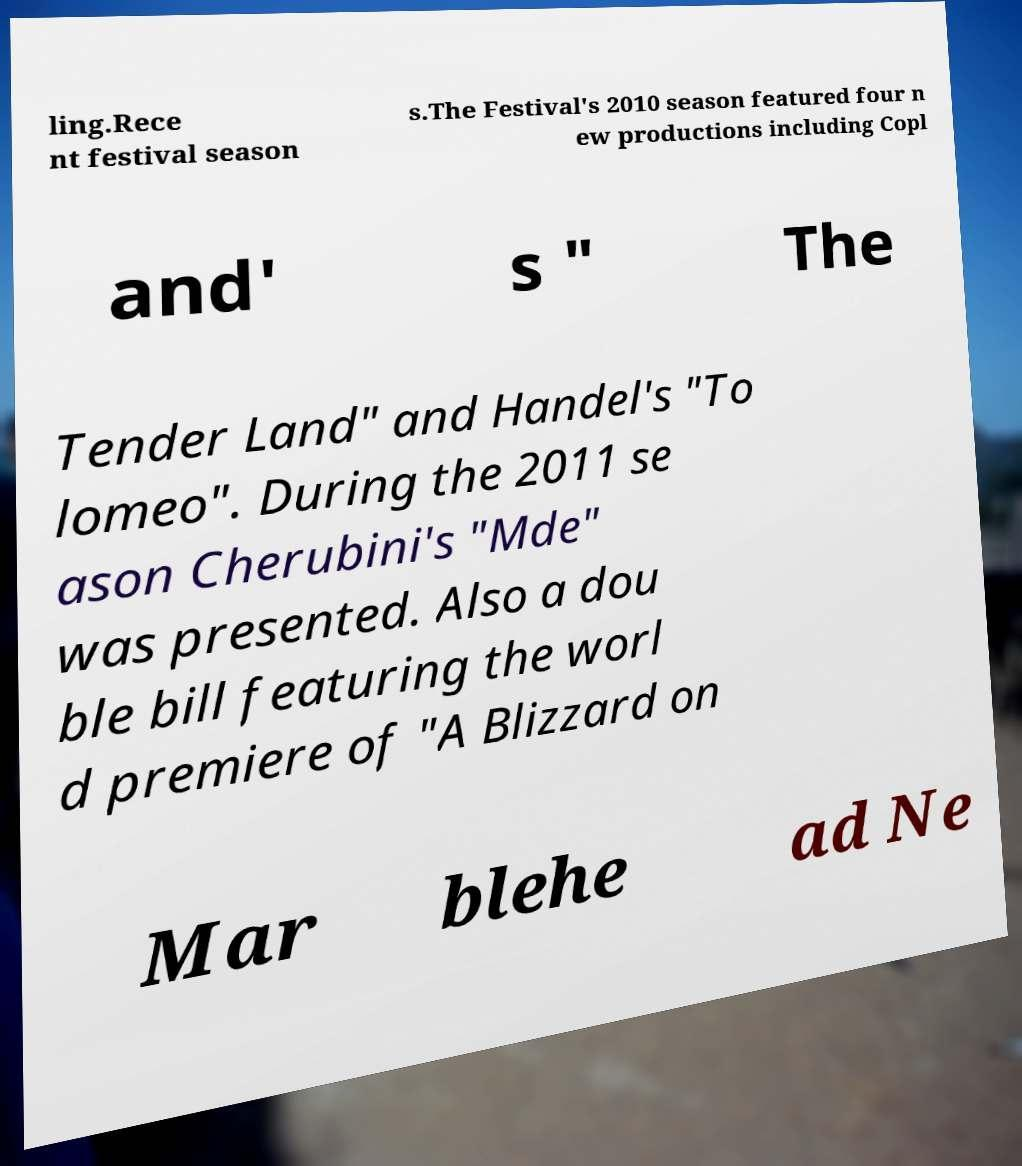There's text embedded in this image that I need extracted. Can you transcribe it verbatim? ling.Rece nt festival season s.The Festival's 2010 season featured four n ew productions including Copl and' s " The Tender Land" and Handel's "To lomeo". During the 2011 se ason Cherubini's "Mde" was presented. Also a dou ble bill featuring the worl d premiere of "A Blizzard on Mar blehe ad Ne 